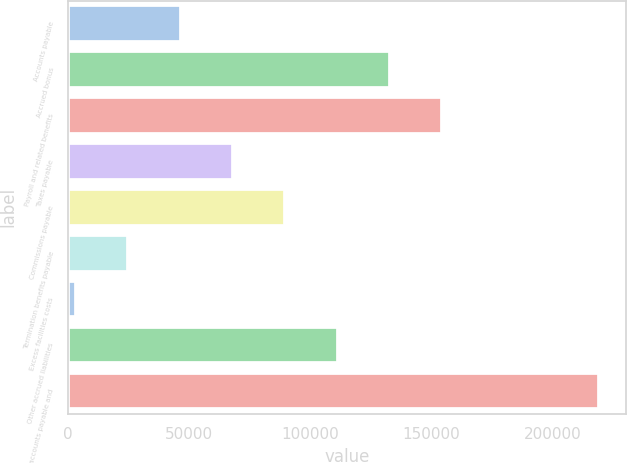Convert chart to OTSL. <chart><loc_0><loc_0><loc_500><loc_500><bar_chart><fcel>Accounts payable<fcel>Accrued bonus<fcel>Payroll and related benefits<fcel>Taxes payable<fcel>Commissions payable<fcel>Termination benefits payable<fcel>Excess facilities costs<fcel>Other accrued liabilities<fcel>Total accounts payable and<nl><fcel>46525<fcel>132953<fcel>154560<fcel>68132<fcel>89739<fcel>24918<fcel>3311<fcel>111346<fcel>219381<nl></chart> 